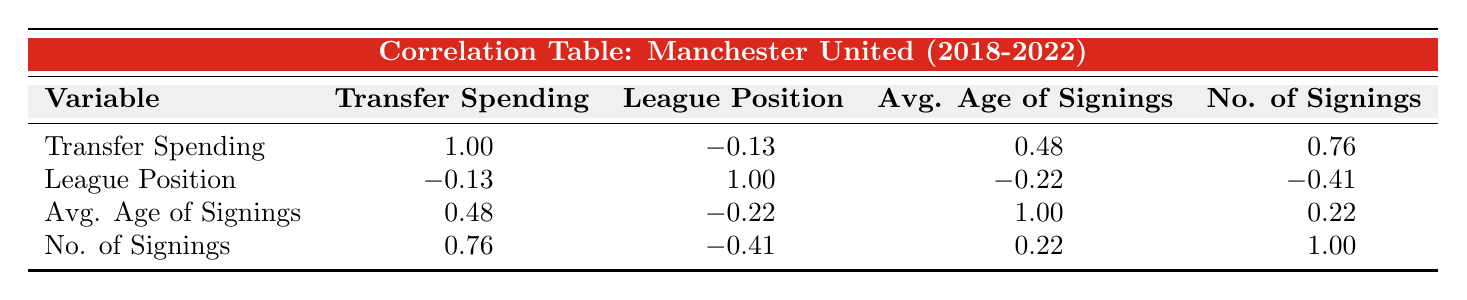What was Manchester United's highest transfer spending over the five years? The highest transfer spending can be found by comparing the amounts in the "Transfer Spending" row. The values are 75.3, 130.2, 41.5, 95.0, and 80.0 million. The highest value is 130.2 million in 2019.
Answer: 130.2 million What is the league position when Manchester United spent the least on transfers? To determine this, we look at the "Transfer Spending" values to find the lowest amount. The least transfer spending is 41.5 million in 2020, which corresponds to a league position of 3.
Answer: 3 Is there a negative correlation between transfer spending and league position? The correlation coefficient between "Transfer Spending" and "League Position" is -0.13, which indicates a very weak negative correlation, showing that they do not move together in a significant way.
Answer: Yes What is the average age of signings in the year with the highest number of signings? The highest number of signings corresponds to six signings in 2019. The average age of signings that year is 26.1, which can be directly read from the "Avg. Age of Signings" row.
Answer: 26.1 What is the correlation between the number of signings and transfer spending? The correlation between "No. of Signings" and "Transfer Spending" is 0.76. This indicates a strong positive correlation, meaning that as the number of signings increases, transfer spending tends to increase as well.
Answer: 0.76 What was the league position in the year when the average age of signings was lowest? The year with the lowest "Avg. Age of Signings" is 2022, with an average age of 24.7, which correlates with a league position of 6.
Answer: 6 Based on the data, did Manchester United improve their league position after a significant increase in transfer spending? Comparing years with significant transfer spending increases to league positions shows that in 2018 to 2019, spending increased from 75.3 to 130.2 million, but the league position dropped from 2 to 6. Thus, this indicates no improvement in league position despite increased spending.
Answer: No What is the total transfer spending over the five years? To find the total transfer spending, sum the values: 75.3 + 130.2 + 41.5 + 95.0 + 80.0 = 422.0 million.
Answer: 422.0 million 